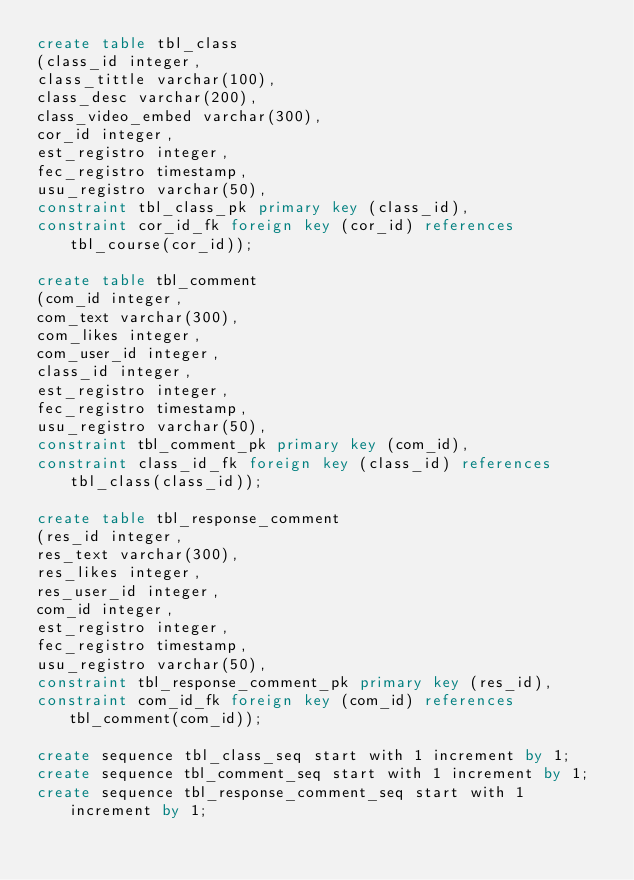Convert code to text. <code><loc_0><loc_0><loc_500><loc_500><_SQL_>create table tbl_class
(class_id integer,
class_tittle varchar(100),
class_desc varchar(200),
class_video_embed varchar(300),
cor_id integer,
est_registro integer,
fec_registro timestamp,
usu_registro varchar(50),
constraint tbl_class_pk primary key (class_id),
constraint cor_id_fk foreign key (cor_id) references tbl_course(cor_id));

create table tbl_comment
(com_id integer,
com_text varchar(300),
com_likes integer,
com_user_id integer,
class_id integer,
est_registro integer,
fec_registro timestamp,
usu_registro varchar(50),
constraint tbl_comment_pk primary key (com_id),
constraint class_id_fk foreign key (class_id) references tbl_class(class_id));

create table tbl_response_comment
(res_id integer,
res_text varchar(300),
res_likes integer,
res_user_id integer,
com_id integer,
est_registro integer,
fec_registro timestamp,
usu_registro varchar(50),
constraint tbl_response_comment_pk primary key (res_id),
constraint com_id_fk foreign key (com_id) references tbl_comment(com_id));

create sequence tbl_class_seq start with 1 increment by 1;
create sequence tbl_comment_seq start with 1 increment by 1;
create sequence tbl_response_comment_seq start with 1 increment by 1;</code> 